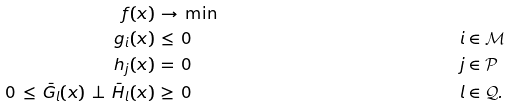Convert formula to latex. <formula><loc_0><loc_0><loc_500><loc_500>f ( x ) & \, \to \, \min & & & \\ g _ { i } ( x ) & \, \leq \, 0 & \quad & i \in \mathcal { M } & \\ h _ { j } ( x ) & \, = \, 0 & & j \in \mathcal { P } & \\ 0 \, \leq \, \bar { G } _ { l } ( x ) \, \perp \, \bar { H } _ { l } ( x ) & \, \geq \, 0 & & l \in \mathcal { Q } . &</formula> 